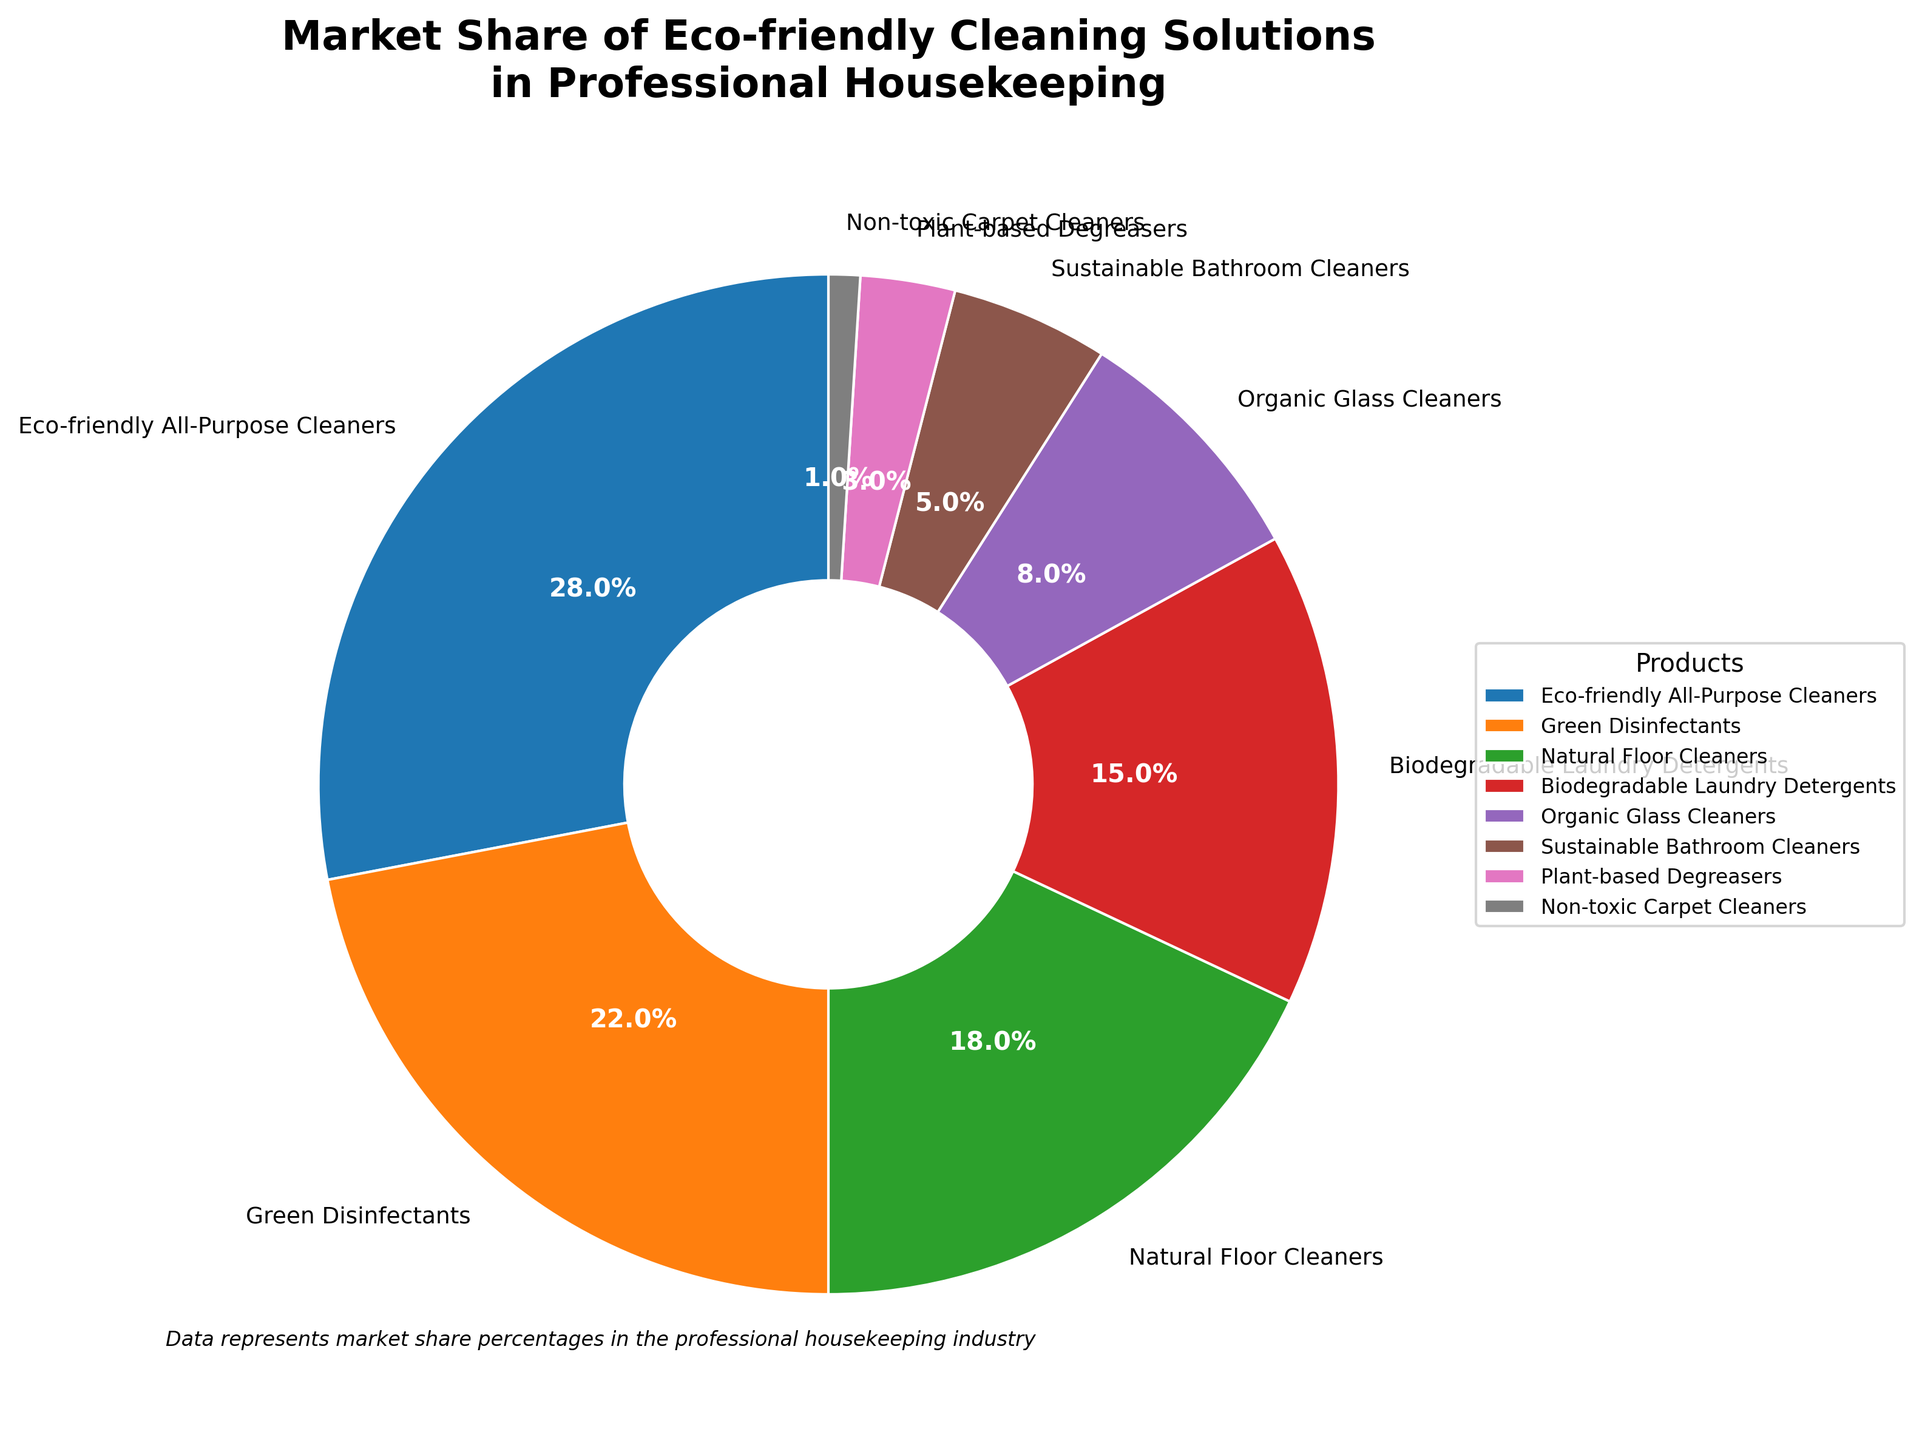What is the market share of the most popular eco-friendly cleaning solution? The figure shows that Eco-friendly All-Purpose Cleaners have the largest market share. By checking the labels and percentages, we see that it holds 28% of the market.
Answer: 28% Which product has the least market share? By examining the pie chart and corresponding labels, we identify Non-toxic Carpet Cleaners as having the smallest market share, which is 1%.
Answer: Non-toxic Carpet Cleaners How much greater is the market share of Biodegradable Laundry Detergents compared to Organic Glass Cleaners? The market share of Biodegradable Laundry Detergents is 15%, and the market share of Organic Glass Cleaners is 8%. The difference between these two is calculated as 15% - 8% = 7%.
Answer: 7% What is the combined market share of Natural Floor Cleaners and Green Disinfectants? Natural Floor Cleaners have a market share of 18%, and Green Disinfectants have a share of 22%. Adding these together, 18% + 22%, we get 40%.
Answer: 40% Which products share the same color family in the pie chart, and what are their market shares? By visually identifying the colors, Sustainable Bathroom Cleaners and Plant-based Degreasers have similar shades of brown. Their market shares are 5% and 3%, respectively.
Answer: Sustainable Bathroom Cleaners: 5%, Plant-based Degreasers: 3% Which two products together account for more than half of the market share? From the chart, Eco-friendly All-Purpose Cleaners have 28% and Green Disinfectants have 22%. Their combined share is 28% + 22% = 50%, which constitutes exactly half of the market. To account for more than half, we also need to add another product. Adding Natural Floor Cleaners (18%) to the combination results in 28% + 22% + 18% = 68%, which is more than 50%. Therefore, Eco-friendly All-Purpose Cleaners and Green Disinfectants combined already account for 50%, but adding Natural Floor Cleaners makes it more than half.
Answer: Eco-friendly All-Purpose Cleaners and Green Disinfectants What fraction of the market is occupied by products other than Eco-friendly All-Purpose Cleaners? The market share of Eco-friendly All-Purpose Cleaners is 28%. Therefore, the remaining market share, occupied by other products, is 100% - 28% = 72%.
Answer: 72% Which product categories combined hold less than 20% market share? Examining the chart, we see that Plant-based Degreasers (3%) and Non-toxic Carpet Cleaners (1%) combined hold 4%. Also, Sustainable Bathroom Cleaners (5%) and Organic Glass Cleaners (8%) combined hold 13%. Adding these percentages to another category to stay under 20%, we find that Biodegradable Laundry Detergents (15%) added to any other small share surpasses 20%. So, Plant-based Degreasers (3%) and Non-toxic Carpet Cleaners (1%) together with Sustainable Bathroom Cleaners (5%) are less than 20%.
Answer: Plant-based Degreasers and Non-toxic Carpet Cleaners together with Sustainable Bathroom Cleaners Is the market share of Green Disinfectants more than twice that of Biodegradable Laundry Detergents? The market share of Green Disinfectants is 22%, while Biodegradable Laundry Detergents hold 15%. Doubling the market share of Biodegradable Laundry Detergents gives us 15% * 2 = 30%, which is greater than 22%. Hence, Green Disinfectants do not have more than twice the share of Biodegradable Laundry Detergents.
Answer: No 